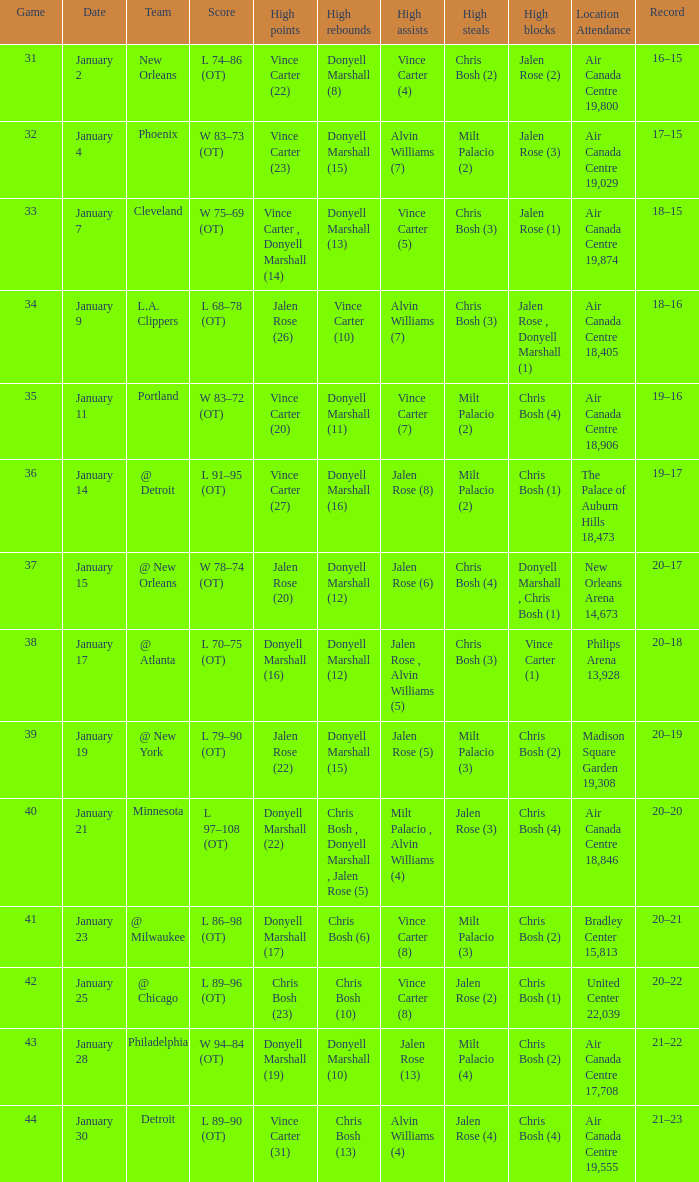Where was the game, and how many attended the game on january 2? Air Canada Centre 19,800. 